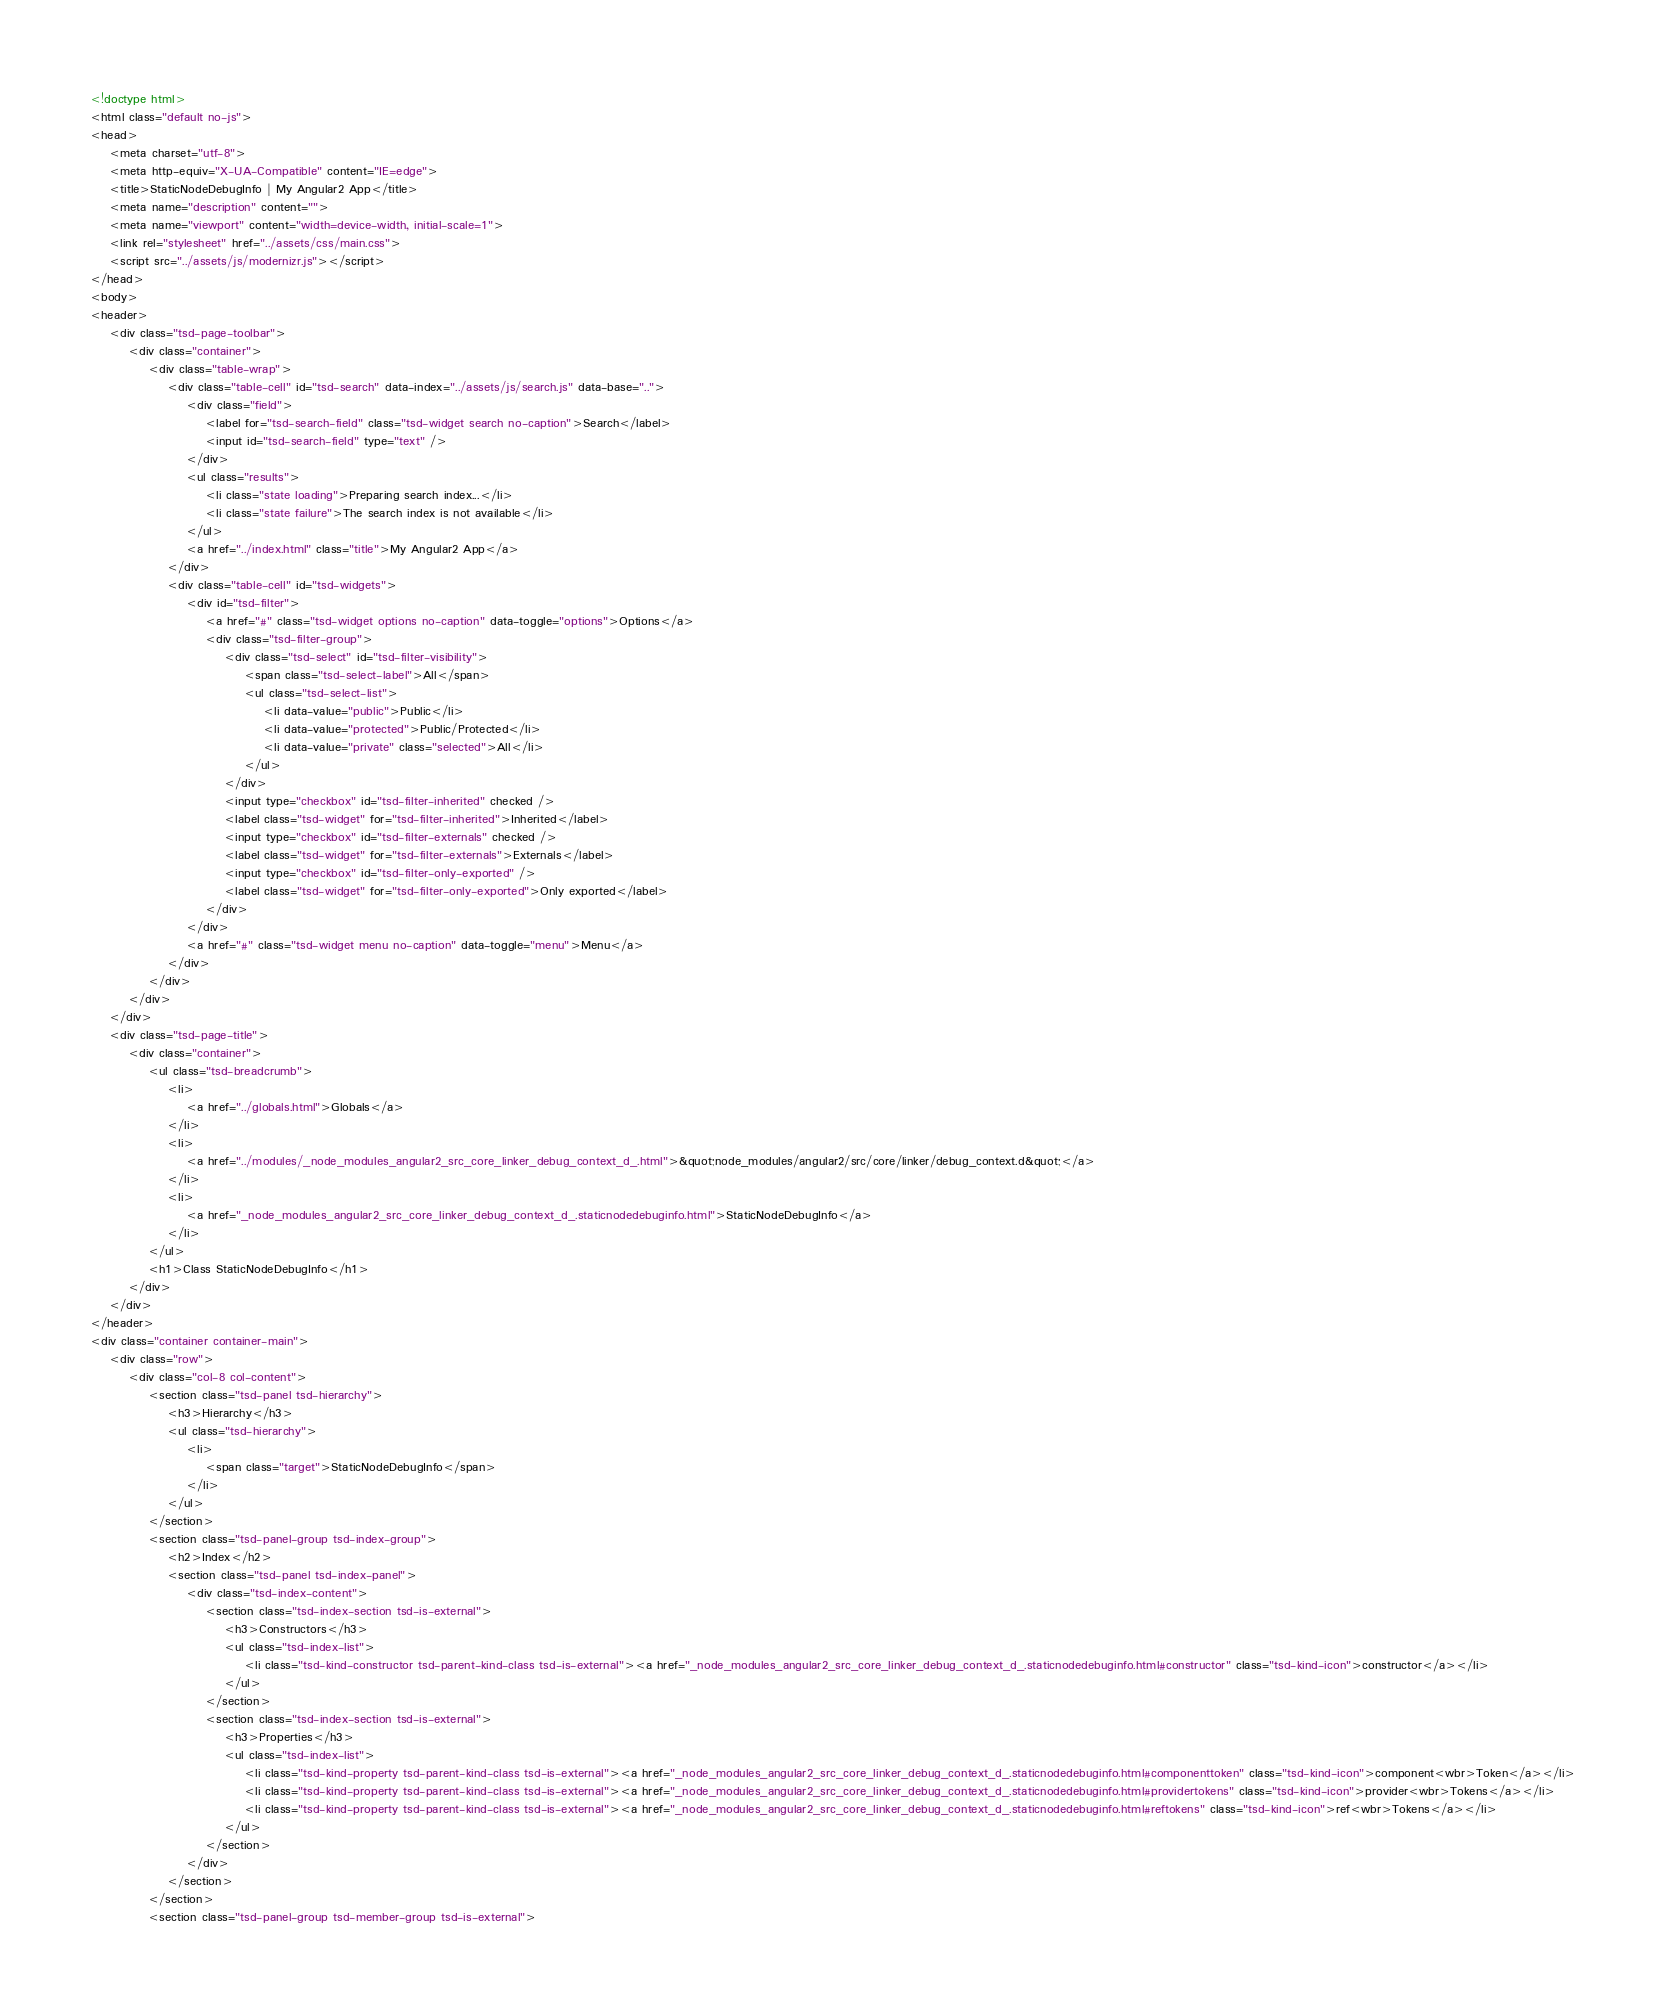Convert code to text. <code><loc_0><loc_0><loc_500><loc_500><_HTML_><!doctype html>
<html class="default no-js">
<head>
	<meta charset="utf-8">
	<meta http-equiv="X-UA-Compatible" content="IE=edge">
	<title>StaticNodeDebugInfo | My Angular2 App</title>
	<meta name="description" content="">
	<meta name="viewport" content="width=device-width, initial-scale=1">
	<link rel="stylesheet" href="../assets/css/main.css">
	<script src="../assets/js/modernizr.js"></script>
</head>
<body>
<header>
	<div class="tsd-page-toolbar">
		<div class="container">
			<div class="table-wrap">
				<div class="table-cell" id="tsd-search" data-index="../assets/js/search.js" data-base="..">
					<div class="field">
						<label for="tsd-search-field" class="tsd-widget search no-caption">Search</label>
						<input id="tsd-search-field" type="text" />
					</div>
					<ul class="results">
						<li class="state loading">Preparing search index...</li>
						<li class="state failure">The search index is not available</li>
					</ul>
					<a href="../index.html" class="title">My Angular2 App</a>
				</div>
				<div class="table-cell" id="tsd-widgets">
					<div id="tsd-filter">
						<a href="#" class="tsd-widget options no-caption" data-toggle="options">Options</a>
						<div class="tsd-filter-group">
							<div class="tsd-select" id="tsd-filter-visibility">
								<span class="tsd-select-label">All</span>
								<ul class="tsd-select-list">
									<li data-value="public">Public</li>
									<li data-value="protected">Public/Protected</li>
									<li data-value="private" class="selected">All</li>
								</ul>
							</div>
							<input type="checkbox" id="tsd-filter-inherited" checked />
							<label class="tsd-widget" for="tsd-filter-inherited">Inherited</label>
							<input type="checkbox" id="tsd-filter-externals" checked />
							<label class="tsd-widget" for="tsd-filter-externals">Externals</label>
							<input type="checkbox" id="tsd-filter-only-exported" />
							<label class="tsd-widget" for="tsd-filter-only-exported">Only exported</label>
						</div>
					</div>
					<a href="#" class="tsd-widget menu no-caption" data-toggle="menu">Menu</a>
				</div>
			</div>
		</div>
	</div>
	<div class="tsd-page-title">
		<div class="container">
			<ul class="tsd-breadcrumb">
				<li>
					<a href="../globals.html">Globals</a>
				</li>
				<li>
					<a href="../modules/_node_modules_angular2_src_core_linker_debug_context_d_.html">&quot;node_modules/angular2/src/core/linker/debug_context.d&quot;</a>
				</li>
				<li>
					<a href="_node_modules_angular2_src_core_linker_debug_context_d_.staticnodedebuginfo.html">StaticNodeDebugInfo</a>
				</li>
			</ul>
			<h1>Class StaticNodeDebugInfo</h1>
		</div>
	</div>
</header>
<div class="container container-main">
	<div class="row">
		<div class="col-8 col-content">
			<section class="tsd-panel tsd-hierarchy">
				<h3>Hierarchy</h3>
				<ul class="tsd-hierarchy">
					<li>
						<span class="target">StaticNodeDebugInfo</span>
					</li>
				</ul>
			</section>
			<section class="tsd-panel-group tsd-index-group">
				<h2>Index</h2>
				<section class="tsd-panel tsd-index-panel">
					<div class="tsd-index-content">
						<section class="tsd-index-section tsd-is-external">
							<h3>Constructors</h3>
							<ul class="tsd-index-list">
								<li class="tsd-kind-constructor tsd-parent-kind-class tsd-is-external"><a href="_node_modules_angular2_src_core_linker_debug_context_d_.staticnodedebuginfo.html#constructor" class="tsd-kind-icon">constructor</a></li>
							</ul>
						</section>
						<section class="tsd-index-section tsd-is-external">
							<h3>Properties</h3>
							<ul class="tsd-index-list">
								<li class="tsd-kind-property tsd-parent-kind-class tsd-is-external"><a href="_node_modules_angular2_src_core_linker_debug_context_d_.staticnodedebuginfo.html#componenttoken" class="tsd-kind-icon">component<wbr>Token</a></li>
								<li class="tsd-kind-property tsd-parent-kind-class tsd-is-external"><a href="_node_modules_angular2_src_core_linker_debug_context_d_.staticnodedebuginfo.html#providertokens" class="tsd-kind-icon">provider<wbr>Tokens</a></li>
								<li class="tsd-kind-property tsd-parent-kind-class tsd-is-external"><a href="_node_modules_angular2_src_core_linker_debug_context_d_.staticnodedebuginfo.html#reftokens" class="tsd-kind-icon">ref<wbr>Tokens</a></li>
							</ul>
						</section>
					</div>
				</section>
			</section>
			<section class="tsd-panel-group tsd-member-group tsd-is-external"></code> 